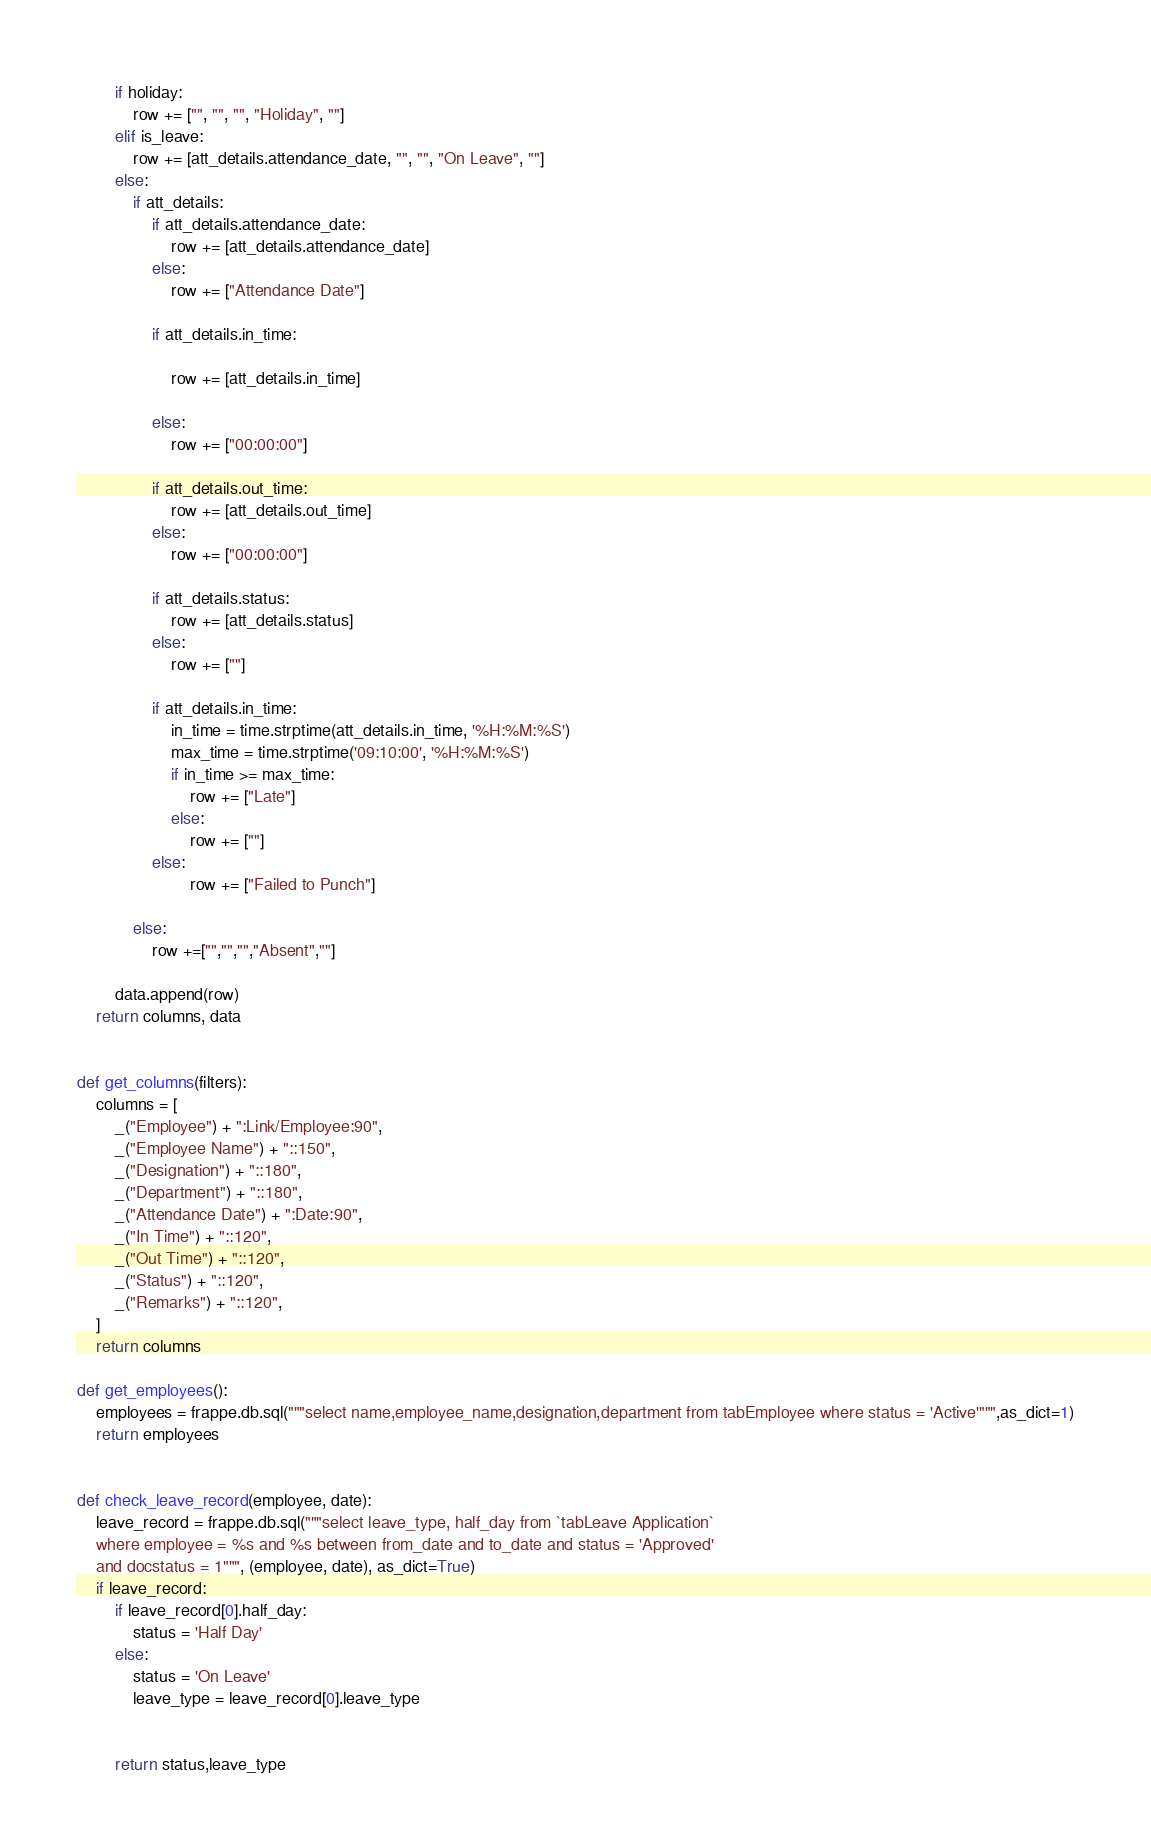Convert code to text. <code><loc_0><loc_0><loc_500><loc_500><_Python_>        if holiday:
            row += ["", "", "", "Holiday", ""]
        elif is_leave:
            row += [att_details.attendance_date, "", "", "On Leave", ""]
        else:    
            if att_details:
                if att_details.attendance_date:
                    row += [att_details.attendance_date]
                else:
                    row += ["Attendance Date"]

                if att_details.in_time:
                       
                    row += [att_details.in_time]
                    
                else:
                    row += ["00:00:00"]

                if att_details.out_time:
                    row += [att_details.out_time]
                else:
                    row += ["00:00:00"]
                 
                if att_details.status: 
                    row += [att_details.status]
                else:
                    row += [""]

                if att_details.in_time:
                    in_time = time.strptime(att_details.in_time, '%H:%M:%S')
                    max_time = time.strptime('09:10:00', '%H:%M:%S') 
                    if in_time >= max_time:
                        row += ["Late"]
                    else:
                        row += [""]    
                else:
                        row += ["Failed to Punch"] 

            else:
                row +=["","","","Absent",""]

        data.append(row)
    return columns, data


def get_columns(filters):
    columns = [
        _("Employee") + ":Link/Employee:90",
        _("Employee Name") + "::150",
        _("Designation") + "::180",
        _("Department") + "::180",
        _("Attendance Date") + ":Date:90",
        _("In Time") + "::120",
        _("Out Time") + "::120",
        _("Status") + "::120",
        _("Remarks") + "::120",
    ]
    return columns

def get_employees():
    employees = frappe.db.sql("""select name,employee_name,designation,department from tabEmployee where status = 'Active'""",as_dict=1)
    return employees


def check_leave_record(employee, date):
    leave_record = frappe.db.sql("""select leave_type, half_day from `tabLeave Application`
    where employee = %s and %s between from_date and to_date and status = 'Approved'
    and docstatus = 1""", (employee, date), as_dict=True)
    if leave_record:
        if leave_record[0].half_day:
            status = 'Half Day'
        else:
            status = 'On Leave'
            leave_type = leave_record[0].leave_type
            

        return status,leave_type 
</code> 